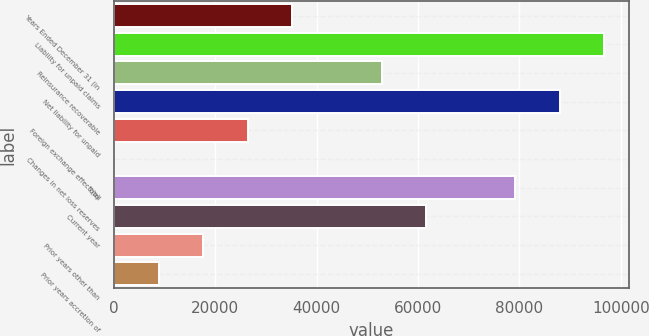<chart> <loc_0><loc_0><loc_500><loc_500><bar_chart><fcel>Years Ended December 31 (in<fcel>Liability for unpaid claims<fcel>Reinsurance recoverable<fcel>Net liability for unpaid<fcel>Foreign exchange effect (a)<fcel>Changes in net loss reserves<fcel>Total<fcel>Current year<fcel>Prior years other than<fcel>Prior years accretion of<nl><fcel>35209.6<fcel>96787.9<fcel>52803.4<fcel>87991<fcel>26412.7<fcel>22<fcel>79194.1<fcel>61600.3<fcel>17615.8<fcel>8818.9<nl></chart> 